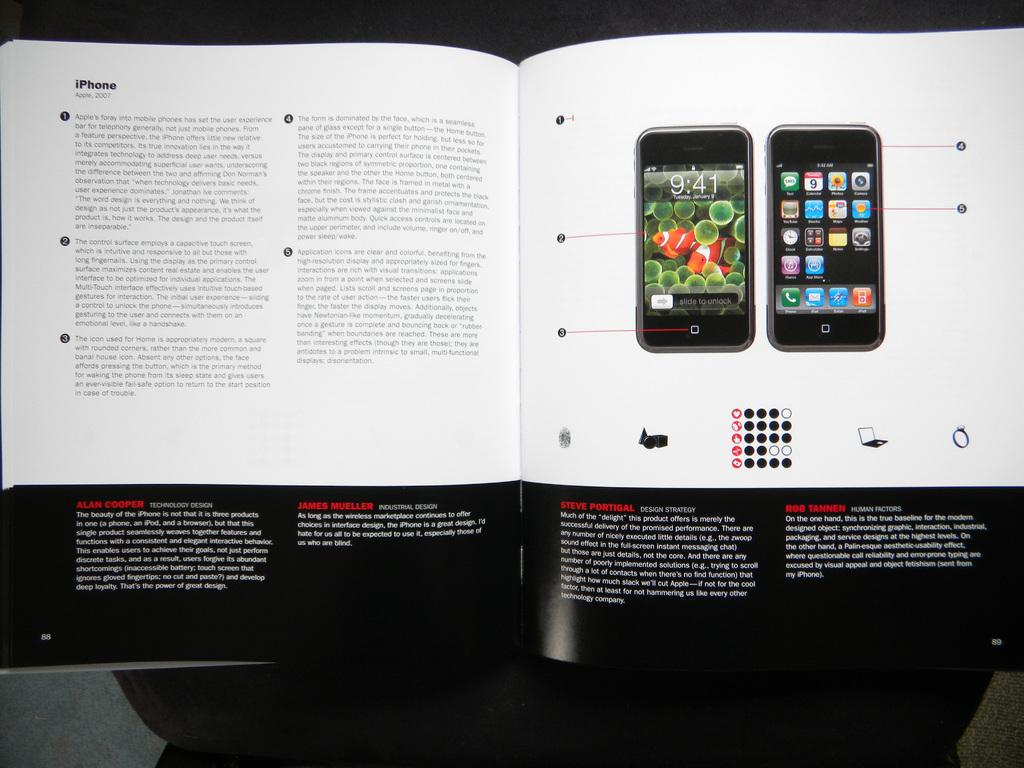Provide a one-sentence caption for the provided image. A book displaying an iPhone with one section titled Steve Portigal. 